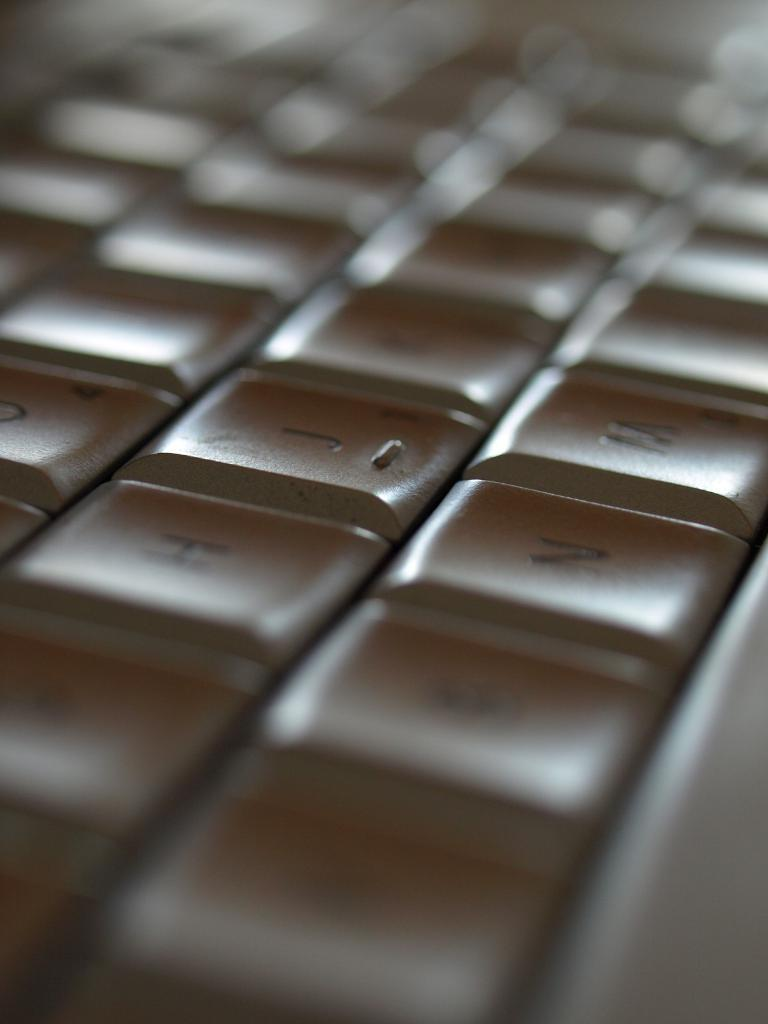What is the main object in the image? There is a keyboard in the image. How many cats are sitting on the keyboard in the image? There are no cats present in the image; it only features a keyboard. What type of umbrella is being used to cover the keyboard in the image? There is no umbrella present in the image; it only features a keyboard. 